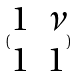Convert formula to latex. <formula><loc_0><loc_0><loc_500><loc_500>( \begin{matrix} 1 & \nu \\ 1 & 1 \end{matrix} )</formula> 